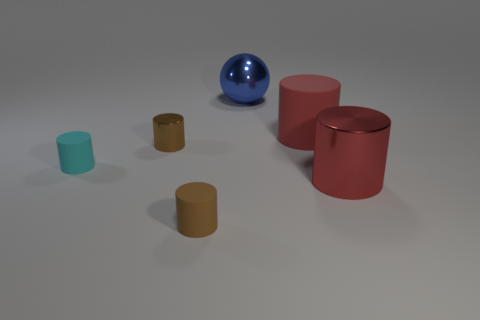Subtract all large metal cylinders. How many cylinders are left? 4 Subtract all cyan cylinders. How many cylinders are left? 4 Subtract all yellow cylinders. Subtract all gray cubes. How many cylinders are left? 5 Add 2 red metal objects. How many objects exist? 8 Subtract all cylinders. How many objects are left? 1 Subtract all blue shiny things. Subtract all brown metal cylinders. How many objects are left? 4 Add 5 big red rubber things. How many big red rubber things are left? 6 Add 1 red metallic things. How many red metallic things exist? 2 Subtract 0 blue cylinders. How many objects are left? 6 